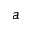Convert formula to latex. <formula><loc_0><loc_0><loc_500><loc_500>a</formula> 